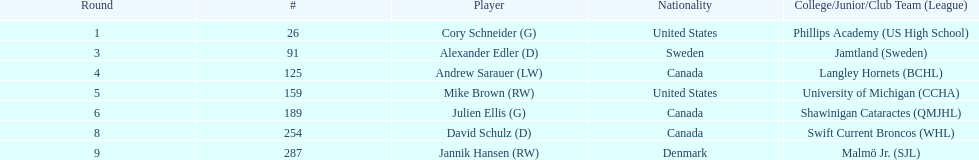Who is the only player to have denmark listed as their nationality? Jannik Hansen (RW). 